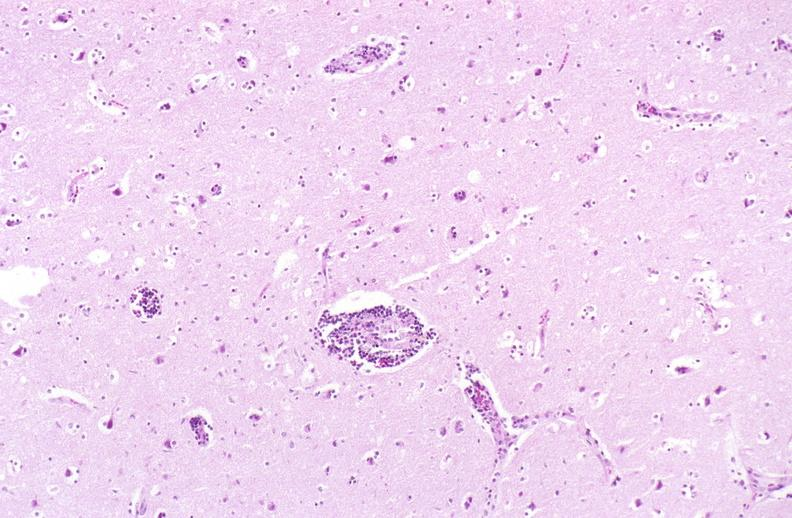does heart show brain, herpes encephalitis, perivascular cuffing?
Answer the question using a single word or phrase. No 